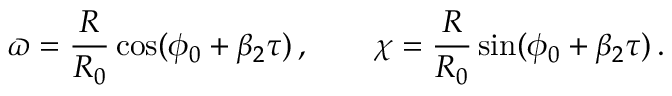<formula> <loc_0><loc_0><loc_500><loc_500>\varpi = \frac { R } { R _ { 0 } } \cos ( \phi _ { 0 } + \beta _ { 2 } \tau ) \, , \quad \chi = \frac { R } { R _ { 0 } } \sin ( \phi _ { 0 } + \beta _ { 2 } \tau ) \, .</formula> 